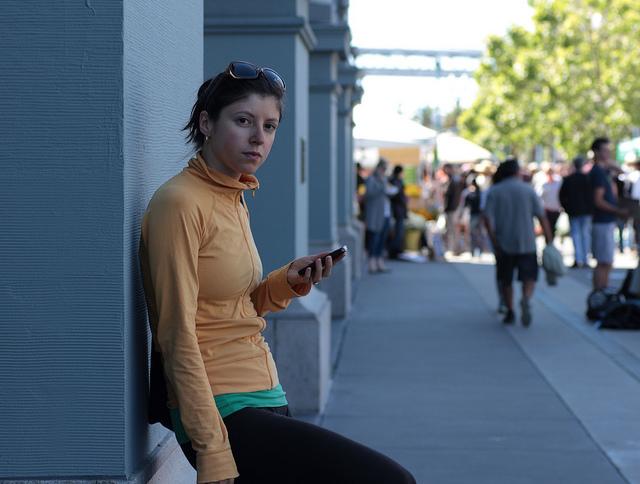What color is the woman's jeans?
Answer briefly. Black. What is the girl sitting on?
Give a very brief answer. Wall. Is the girl trying to throw a frisbee?
Write a very short answer. No. Where are the women's glasses?
Quick response, please. Head. What is the condition of the weather?
Keep it brief. Sunny. What are the women wearing?
Give a very brief answer. Sweatshirt. What color is the woman's jacket?
Be succinct. Yellow. What is this woman have in her ears?
Short answer required. Earrings. How many pieces of individual people are visible in this picture?
Give a very brief answer. Lot. How is the ground?
Quick response, please. Hard. What color is the woman's shirt?
Concise answer only. Yellow. Is she wearing shorts?
Give a very brief answer. No. Is she using her phone?
Concise answer only. Yes. Is she talking on a cell phone?
Short answer required. No. 